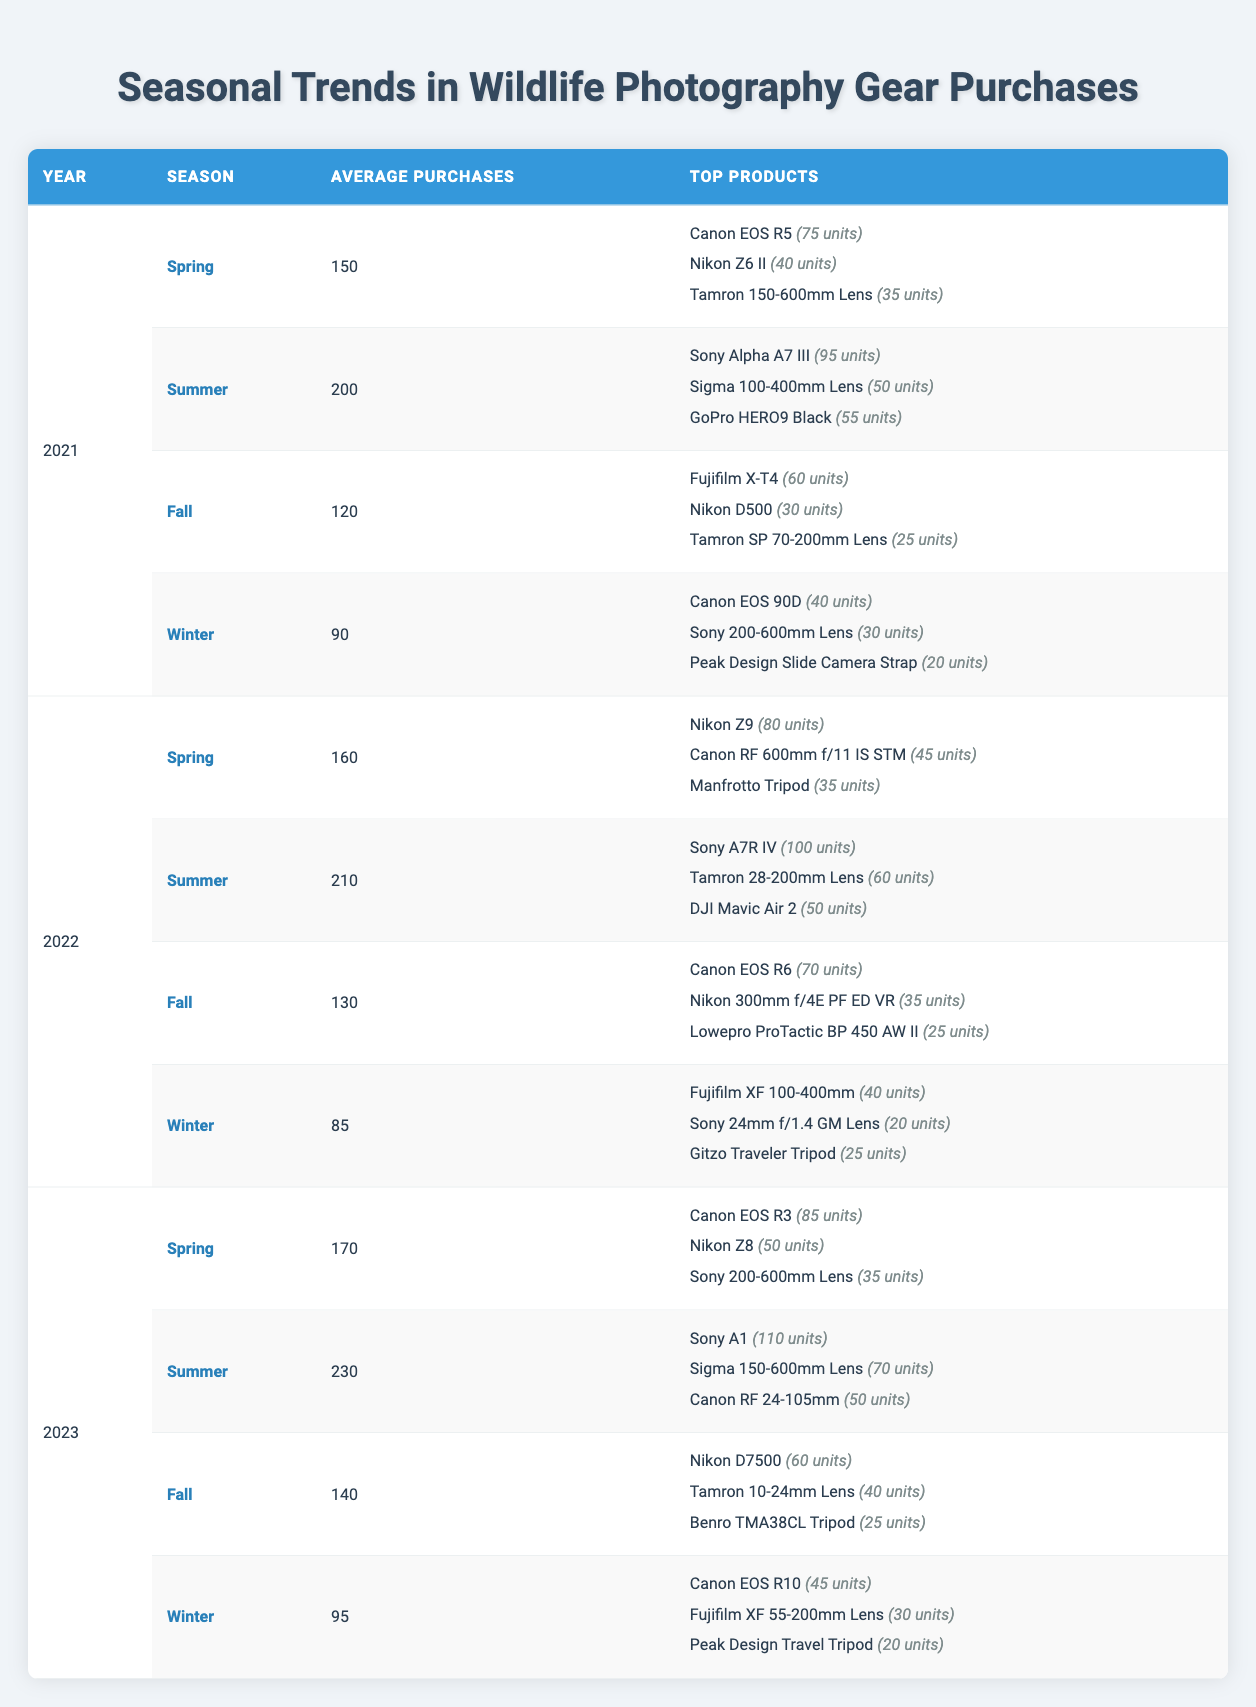What was the average number of purchases in Summer 2022? The table indicates that in Summer 2022, the average purchases were listed as 210.
Answer: 210 Which product sold the most units in Spring 2023? The table shows that in Spring 2023, the Canon EOS R3 had the highest sales with 85 units sold.
Answer: Canon EOS R3 Did more average purchases occur in Summer 2023 compared to Summer 2021? In Summer 2023, the average purchases were 230, while in Summer 2021, it was 200. Since 230 is greater than 200, the answer is yes.
Answer: Yes What is the total number of units sold for the top products in Fall 2022? In Fall 2022, the top products sold were Canon EOS R6 (70 units), Nikon 300mm f/4E PF ED VR (35 units), and Lowepro ProTactic BP 450 AW II (25 units). The total units sold would be 70 + 35 + 25 = 130 units.
Answer: 130 Which season in 2021 had the least average purchases? Reviewing the averages shows Winter 2021 had 90 purchases, the smallest among Spring (150), Summer (200), and Fall (120) which had higher averages.
Answer: Winter How much did the average purchases increase from Spring 2021 to Spring 2022? The average purchases in Spring 2021 were 150, and in Spring 2022 it increased to 160. Therefore, the increase is 160 - 150 = 10.
Answer: 10 Did the top-selling product in Summer 2022 outsell the top product in Winter 2021? In Summer 2022, the top product was Sony A7R IV with 100 units sold, while in Winter 2021, the top product was Canon EOS 90D with 40 units sold. Since 100 exceeds 40, the answer is yes.
Answer: Yes What is the average number of purchases in all seasons for the year 2023? The total average purchases for 2023 sum up to 170 (Spring) + 230 (Summer) + 140 (Fall) + 95 (Winter) = 635. As there are four seasons, the average is 635 / 4 = 158.75, which rounds down to 158 for simplicity.
Answer: 158 Which season had the highest average purchases among the three years presented? A comparison shows that Summer 2023 had the highest average purchases at 230, higher than any other season across the years listed.
Answer: Summer 2023 